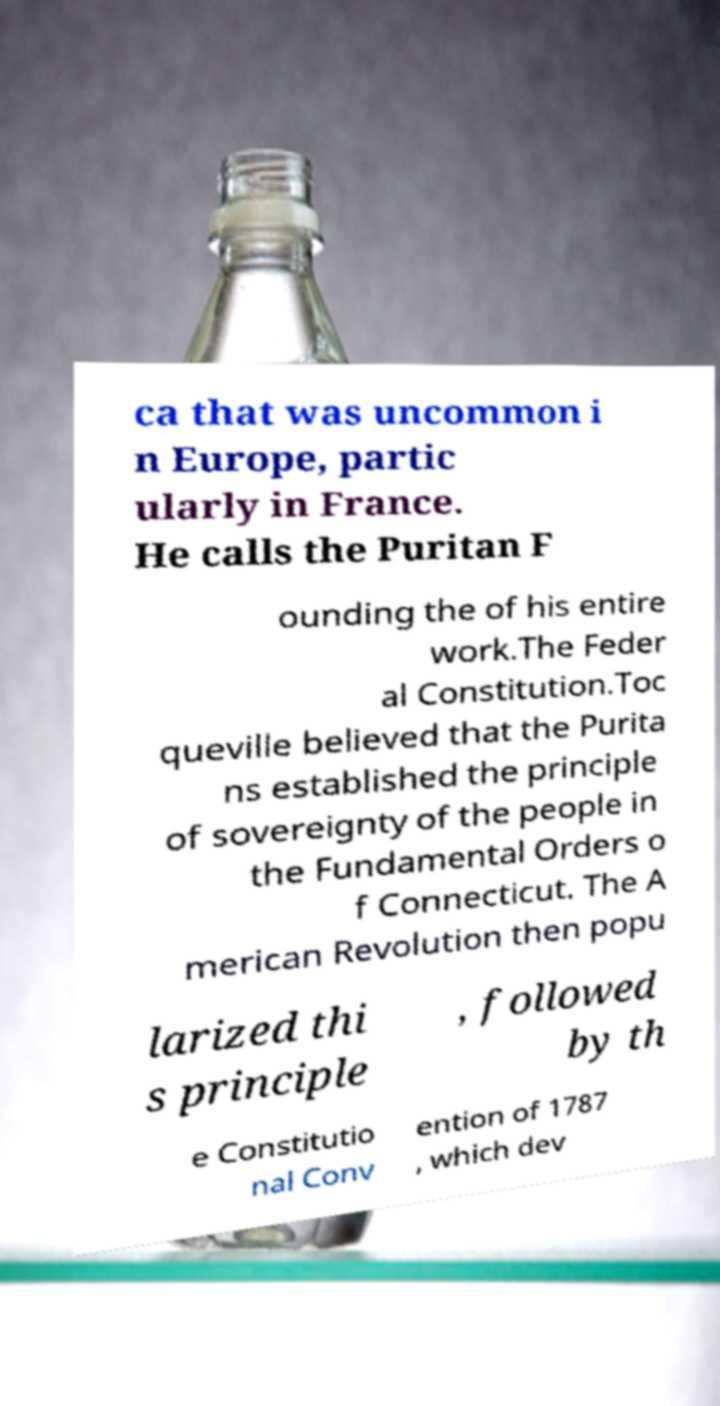Can you accurately transcribe the text from the provided image for me? ca that was uncommon i n Europe, partic ularly in France. He calls the Puritan F ounding the of his entire work.The Feder al Constitution.Toc queville believed that the Purita ns established the principle of sovereignty of the people in the Fundamental Orders o f Connecticut. The A merican Revolution then popu larized thi s principle , followed by th e Constitutio nal Conv ention of 1787 , which dev 